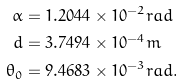Convert formula to latex. <formula><loc_0><loc_0><loc_500><loc_500>\alpha & = 1 . 2 0 4 4 \times 1 0 ^ { - 2 } r a d \\ d & = 3 . 7 4 9 4 \times 1 0 ^ { - 4 } m \\ \theta _ { 0 } & = 9 . 4 6 8 3 \times 1 0 ^ { - 3 } r a d \text {.}</formula> 